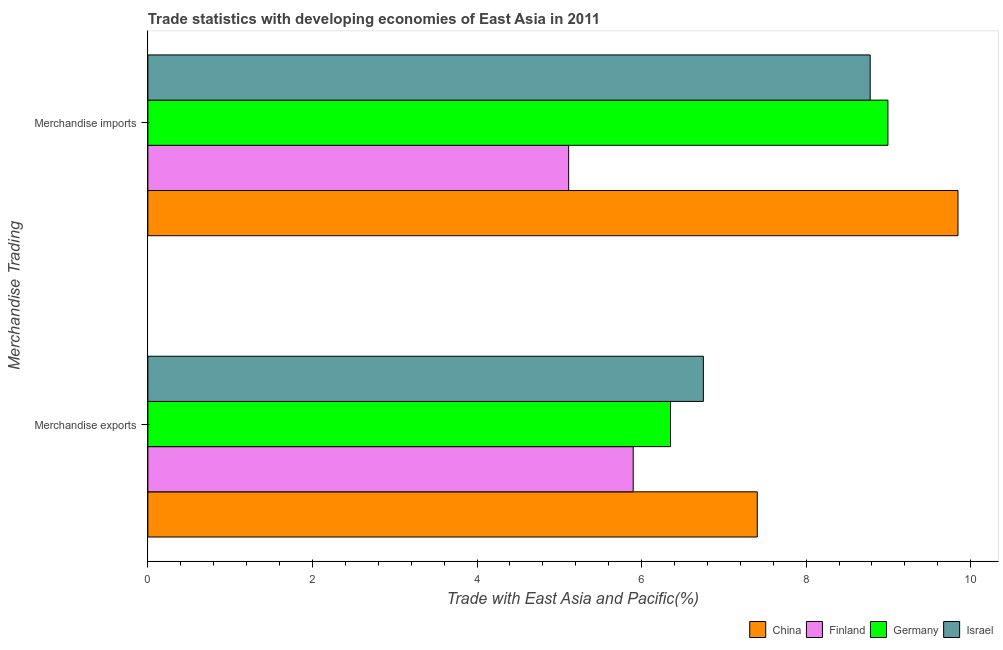How many bars are there on the 2nd tick from the bottom?
Offer a very short reply. 4. What is the label of the 2nd group of bars from the top?
Your response must be concise. Merchandise exports. What is the merchandise imports in Germany?
Keep it short and to the point. 8.99. Across all countries, what is the maximum merchandise exports?
Ensure brevity in your answer.  7.41. Across all countries, what is the minimum merchandise exports?
Make the answer very short. 5.9. In which country was the merchandise exports maximum?
Your answer should be very brief. China. What is the total merchandise exports in the graph?
Offer a terse response. 26.41. What is the difference between the merchandise exports in Israel and that in Finland?
Give a very brief answer. 0.85. What is the difference between the merchandise imports in Israel and the merchandise exports in Finland?
Your answer should be compact. 2.88. What is the average merchandise imports per country?
Offer a terse response. 8.18. What is the difference between the merchandise imports and merchandise exports in Israel?
Provide a succinct answer. 2.03. In how many countries, is the merchandise exports greater than 3.2 %?
Offer a very short reply. 4. What is the ratio of the merchandise exports in China to that in Finland?
Make the answer very short. 1.26. Is the merchandise imports in Germany less than that in China?
Give a very brief answer. Yes. How many bars are there?
Give a very brief answer. 8. How many countries are there in the graph?
Offer a very short reply. 4. Are the values on the major ticks of X-axis written in scientific E-notation?
Ensure brevity in your answer.  No. Where does the legend appear in the graph?
Make the answer very short. Bottom right. How are the legend labels stacked?
Make the answer very short. Horizontal. What is the title of the graph?
Provide a short and direct response. Trade statistics with developing economies of East Asia in 2011. What is the label or title of the X-axis?
Keep it short and to the point. Trade with East Asia and Pacific(%). What is the label or title of the Y-axis?
Your response must be concise. Merchandise Trading. What is the Trade with East Asia and Pacific(%) of China in Merchandise exports?
Make the answer very short. 7.41. What is the Trade with East Asia and Pacific(%) in Finland in Merchandise exports?
Offer a terse response. 5.9. What is the Trade with East Asia and Pacific(%) of Germany in Merchandise exports?
Your answer should be compact. 6.35. What is the Trade with East Asia and Pacific(%) in Israel in Merchandise exports?
Keep it short and to the point. 6.75. What is the Trade with East Asia and Pacific(%) of China in Merchandise imports?
Make the answer very short. 9.85. What is the Trade with East Asia and Pacific(%) in Finland in Merchandise imports?
Provide a succinct answer. 5.11. What is the Trade with East Asia and Pacific(%) of Germany in Merchandise imports?
Your answer should be compact. 8.99. What is the Trade with East Asia and Pacific(%) in Israel in Merchandise imports?
Offer a very short reply. 8.78. Across all Merchandise Trading, what is the maximum Trade with East Asia and Pacific(%) of China?
Offer a terse response. 9.85. Across all Merchandise Trading, what is the maximum Trade with East Asia and Pacific(%) in Finland?
Your answer should be compact. 5.9. Across all Merchandise Trading, what is the maximum Trade with East Asia and Pacific(%) in Germany?
Your answer should be compact. 8.99. Across all Merchandise Trading, what is the maximum Trade with East Asia and Pacific(%) in Israel?
Keep it short and to the point. 8.78. Across all Merchandise Trading, what is the minimum Trade with East Asia and Pacific(%) in China?
Ensure brevity in your answer.  7.41. Across all Merchandise Trading, what is the minimum Trade with East Asia and Pacific(%) in Finland?
Make the answer very short. 5.11. Across all Merchandise Trading, what is the minimum Trade with East Asia and Pacific(%) in Germany?
Keep it short and to the point. 6.35. Across all Merchandise Trading, what is the minimum Trade with East Asia and Pacific(%) in Israel?
Your answer should be compact. 6.75. What is the total Trade with East Asia and Pacific(%) of China in the graph?
Give a very brief answer. 17.25. What is the total Trade with East Asia and Pacific(%) of Finland in the graph?
Provide a short and direct response. 11.01. What is the total Trade with East Asia and Pacific(%) in Germany in the graph?
Keep it short and to the point. 15.35. What is the total Trade with East Asia and Pacific(%) of Israel in the graph?
Ensure brevity in your answer.  15.53. What is the difference between the Trade with East Asia and Pacific(%) in China in Merchandise exports and that in Merchandise imports?
Offer a very short reply. -2.44. What is the difference between the Trade with East Asia and Pacific(%) of Finland in Merchandise exports and that in Merchandise imports?
Offer a very short reply. 0.78. What is the difference between the Trade with East Asia and Pacific(%) in Germany in Merchandise exports and that in Merchandise imports?
Offer a terse response. -2.64. What is the difference between the Trade with East Asia and Pacific(%) in Israel in Merchandise exports and that in Merchandise imports?
Your response must be concise. -2.03. What is the difference between the Trade with East Asia and Pacific(%) in China in Merchandise exports and the Trade with East Asia and Pacific(%) in Finland in Merchandise imports?
Your answer should be very brief. 2.29. What is the difference between the Trade with East Asia and Pacific(%) of China in Merchandise exports and the Trade with East Asia and Pacific(%) of Germany in Merchandise imports?
Make the answer very short. -1.59. What is the difference between the Trade with East Asia and Pacific(%) of China in Merchandise exports and the Trade with East Asia and Pacific(%) of Israel in Merchandise imports?
Offer a terse response. -1.37. What is the difference between the Trade with East Asia and Pacific(%) in Finland in Merchandise exports and the Trade with East Asia and Pacific(%) in Germany in Merchandise imports?
Give a very brief answer. -3.1. What is the difference between the Trade with East Asia and Pacific(%) of Finland in Merchandise exports and the Trade with East Asia and Pacific(%) of Israel in Merchandise imports?
Provide a succinct answer. -2.88. What is the difference between the Trade with East Asia and Pacific(%) in Germany in Merchandise exports and the Trade with East Asia and Pacific(%) in Israel in Merchandise imports?
Your answer should be very brief. -2.43. What is the average Trade with East Asia and Pacific(%) of China per Merchandise Trading?
Keep it short and to the point. 8.63. What is the average Trade with East Asia and Pacific(%) of Finland per Merchandise Trading?
Make the answer very short. 5.51. What is the average Trade with East Asia and Pacific(%) in Germany per Merchandise Trading?
Offer a terse response. 7.67. What is the average Trade with East Asia and Pacific(%) in Israel per Merchandise Trading?
Offer a very short reply. 7.76. What is the difference between the Trade with East Asia and Pacific(%) of China and Trade with East Asia and Pacific(%) of Finland in Merchandise exports?
Offer a terse response. 1.51. What is the difference between the Trade with East Asia and Pacific(%) in China and Trade with East Asia and Pacific(%) in Germany in Merchandise exports?
Ensure brevity in your answer.  1.05. What is the difference between the Trade with East Asia and Pacific(%) of China and Trade with East Asia and Pacific(%) of Israel in Merchandise exports?
Provide a succinct answer. 0.65. What is the difference between the Trade with East Asia and Pacific(%) in Finland and Trade with East Asia and Pacific(%) in Germany in Merchandise exports?
Your response must be concise. -0.45. What is the difference between the Trade with East Asia and Pacific(%) of Finland and Trade with East Asia and Pacific(%) of Israel in Merchandise exports?
Give a very brief answer. -0.85. What is the difference between the Trade with East Asia and Pacific(%) in Germany and Trade with East Asia and Pacific(%) in Israel in Merchandise exports?
Your answer should be compact. -0.4. What is the difference between the Trade with East Asia and Pacific(%) in China and Trade with East Asia and Pacific(%) in Finland in Merchandise imports?
Ensure brevity in your answer.  4.73. What is the difference between the Trade with East Asia and Pacific(%) of China and Trade with East Asia and Pacific(%) of Germany in Merchandise imports?
Your response must be concise. 0.85. What is the difference between the Trade with East Asia and Pacific(%) of China and Trade with East Asia and Pacific(%) of Israel in Merchandise imports?
Offer a very short reply. 1.07. What is the difference between the Trade with East Asia and Pacific(%) of Finland and Trade with East Asia and Pacific(%) of Germany in Merchandise imports?
Provide a short and direct response. -3.88. What is the difference between the Trade with East Asia and Pacific(%) in Finland and Trade with East Asia and Pacific(%) in Israel in Merchandise imports?
Your answer should be compact. -3.66. What is the difference between the Trade with East Asia and Pacific(%) of Germany and Trade with East Asia and Pacific(%) of Israel in Merchandise imports?
Offer a very short reply. 0.22. What is the ratio of the Trade with East Asia and Pacific(%) in China in Merchandise exports to that in Merchandise imports?
Your answer should be very brief. 0.75. What is the ratio of the Trade with East Asia and Pacific(%) in Finland in Merchandise exports to that in Merchandise imports?
Keep it short and to the point. 1.15. What is the ratio of the Trade with East Asia and Pacific(%) of Germany in Merchandise exports to that in Merchandise imports?
Your response must be concise. 0.71. What is the ratio of the Trade with East Asia and Pacific(%) in Israel in Merchandise exports to that in Merchandise imports?
Your answer should be very brief. 0.77. What is the difference between the highest and the second highest Trade with East Asia and Pacific(%) in China?
Provide a short and direct response. 2.44. What is the difference between the highest and the second highest Trade with East Asia and Pacific(%) of Finland?
Offer a very short reply. 0.78. What is the difference between the highest and the second highest Trade with East Asia and Pacific(%) of Germany?
Provide a short and direct response. 2.64. What is the difference between the highest and the second highest Trade with East Asia and Pacific(%) in Israel?
Provide a short and direct response. 2.03. What is the difference between the highest and the lowest Trade with East Asia and Pacific(%) of China?
Your answer should be compact. 2.44. What is the difference between the highest and the lowest Trade with East Asia and Pacific(%) in Finland?
Keep it short and to the point. 0.78. What is the difference between the highest and the lowest Trade with East Asia and Pacific(%) in Germany?
Keep it short and to the point. 2.64. What is the difference between the highest and the lowest Trade with East Asia and Pacific(%) in Israel?
Make the answer very short. 2.03. 